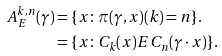<formula> <loc_0><loc_0><loc_500><loc_500>A ^ { k , n } _ { E } ( \gamma ) & = \{ x \colon \pi ( \gamma , x ) ( k ) = n \} . \\ & = \{ x \colon C _ { k } ( x ) E C _ { n } ( \gamma \cdot x ) \} .</formula> 